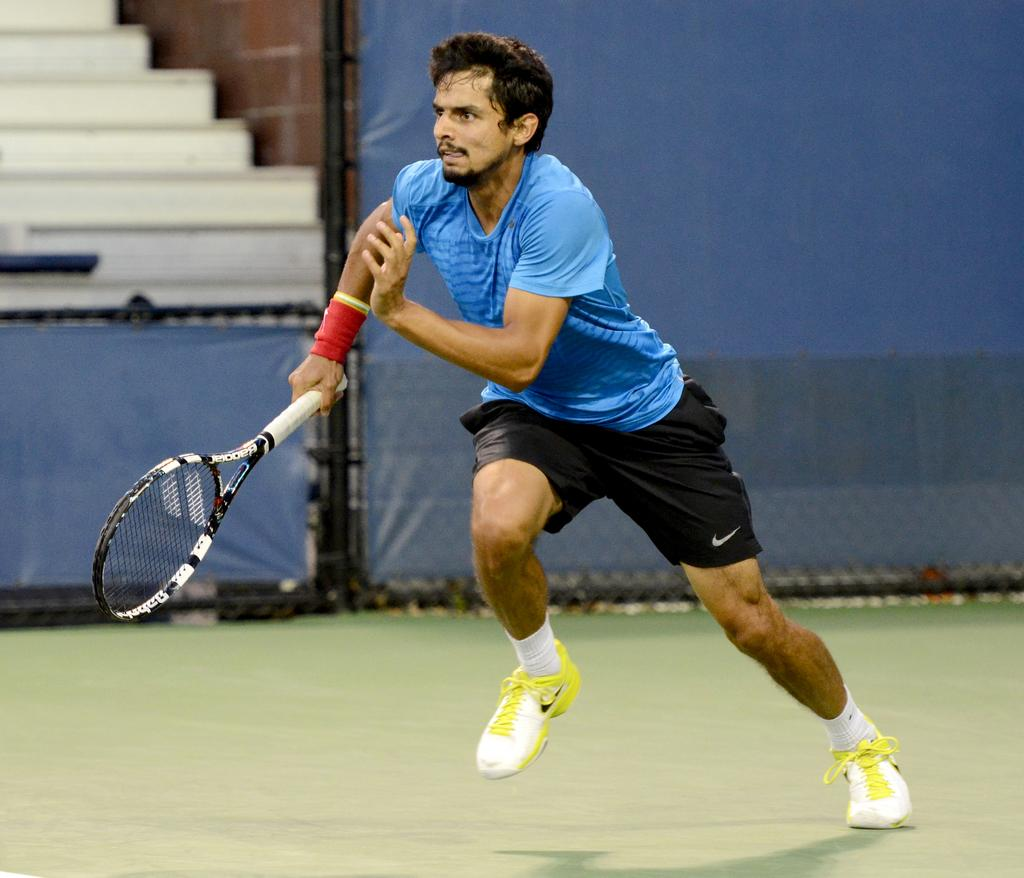What is happening in the image? There is a person in the image, and the person is running. What is the person holding in his hand? The person is holding a tennis racket in his hand. What type of cream can be seen on the person's face in the image? There is no cream visible on the person's face in the image. Who is coaching the person in the image? There is no coach present in the image. 